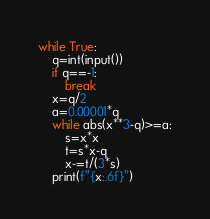<code> <loc_0><loc_0><loc_500><loc_500><_Python_>while True:
    q=int(input())
    if q==-1:
        break
    x=q/2
    a=0.00001*q
    while abs(x**3-q)>=a:
        s=x*x
        t=s*x-q
        x-=t/(3*s)
    print(f"{x:.6f}")
</code> 